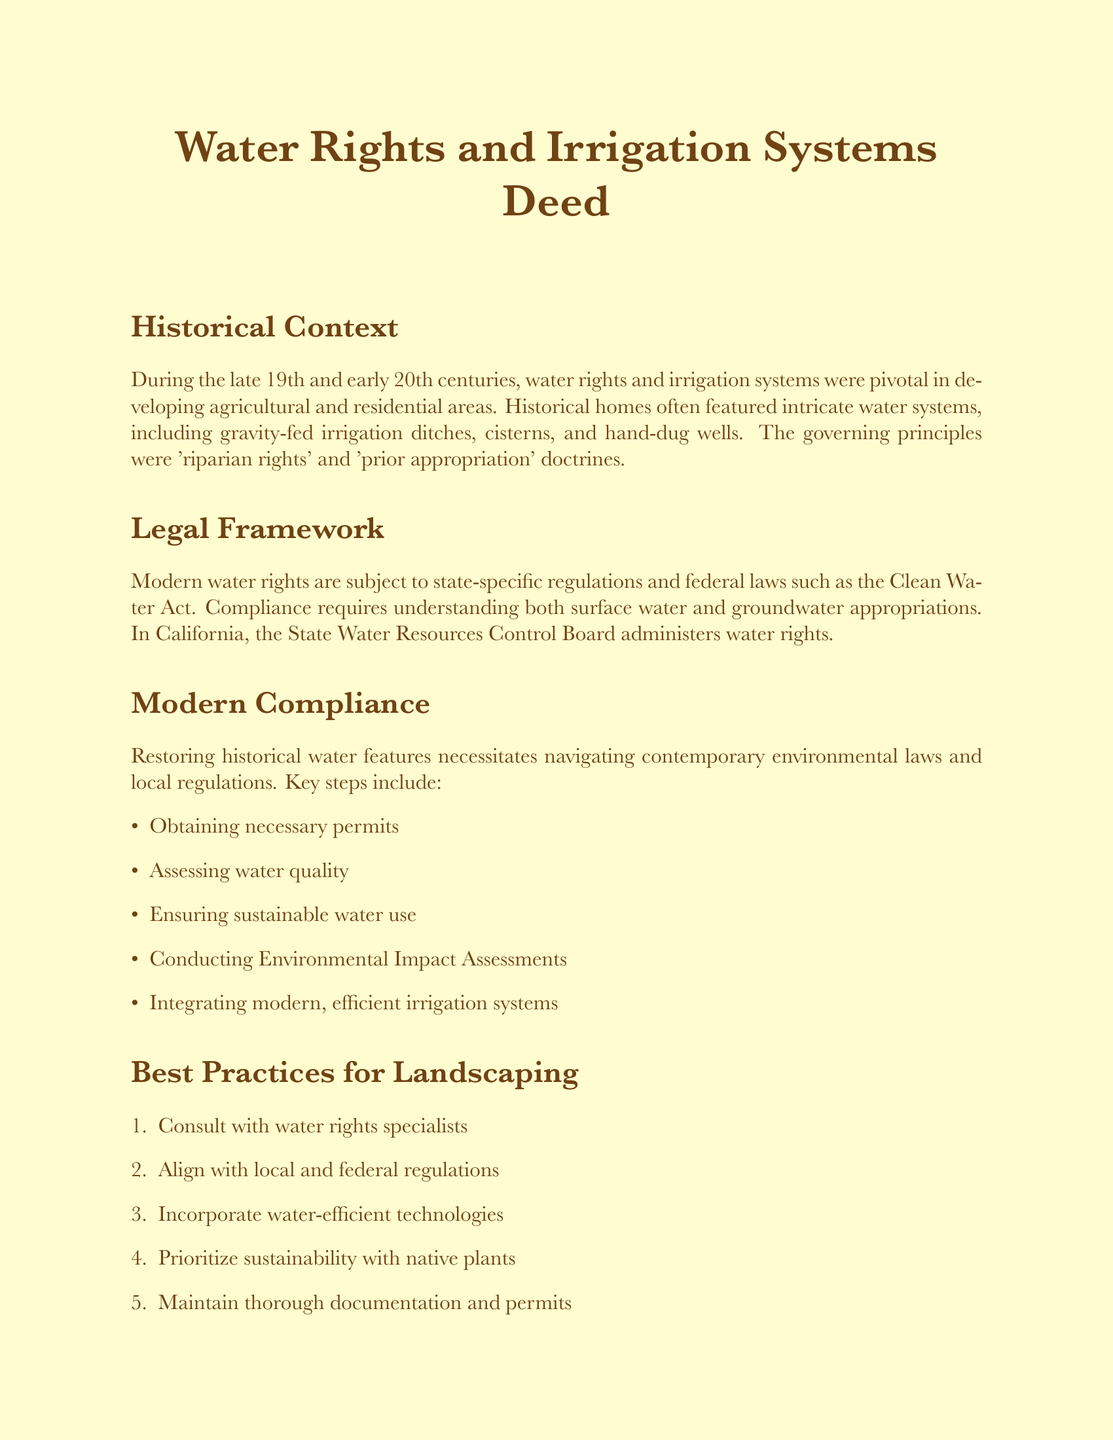What period is highlighted in the historical context? The document mentions the late 19th and early 20th centuries as significant for water rights and irrigation systems.
Answer: late 19th and early 20th centuries What legal structure governs modern water rights in California? The document states that the State Water Resources Control Board administers water rights in California.
Answer: State Water Resources Control Board What are two principles governing historical water rights mentioned in the document? The principles referenced are 'riparian rights' and 'prior appropriation' doctrines.
Answer: riparian rights and prior appropriation What is one key step necessary for restoring historical water features? The document lists obtaining necessary permits as a key step for modern compliance in restoration.
Answer: Obtaining necessary permits What is the first best practice for landscaping mentioned? The document specifies consulting with water rights specialists as the first best practice.
Answer: Consult with water rights specialists What does the deed commit to preserving? The document emphasizes a commitment to preserving historical integrity in water rights and irrigation systems.
Answer: historical integrity What is required to ensure sustainable water use according to the document? The deed highlights the necessity of assessing water quality for sustainable water use.
Answer: Assessing water quality 